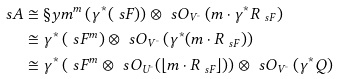Convert formula to latex. <formula><loc_0><loc_0><loc_500><loc_500>\ s A & \cong \S y m ^ { m } \left ( \gamma ^ { * } ( \ s F ) \right ) \otimes \ s O _ { V ^ { \circ } } \left ( m \cdot \gamma ^ { * } R _ { \ s F } \right ) \\ & \cong \gamma ^ { * } \left ( \ s F ^ { m } \right ) \otimes \ s O _ { V ^ { \circ } } \left ( \gamma ^ { * } ( m \cdot R _ { \ s F } ) \right ) \\ & \cong \gamma ^ { * } \left ( \ s F ^ { m } \otimes \ s O _ { U ^ { \circ } } ( \lfloor m \cdot R _ { \ s F } \rfloor ) \right ) \otimes \ s O _ { V ^ { \circ } } \left ( \gamma ^ { * } Q \right )</formula> 